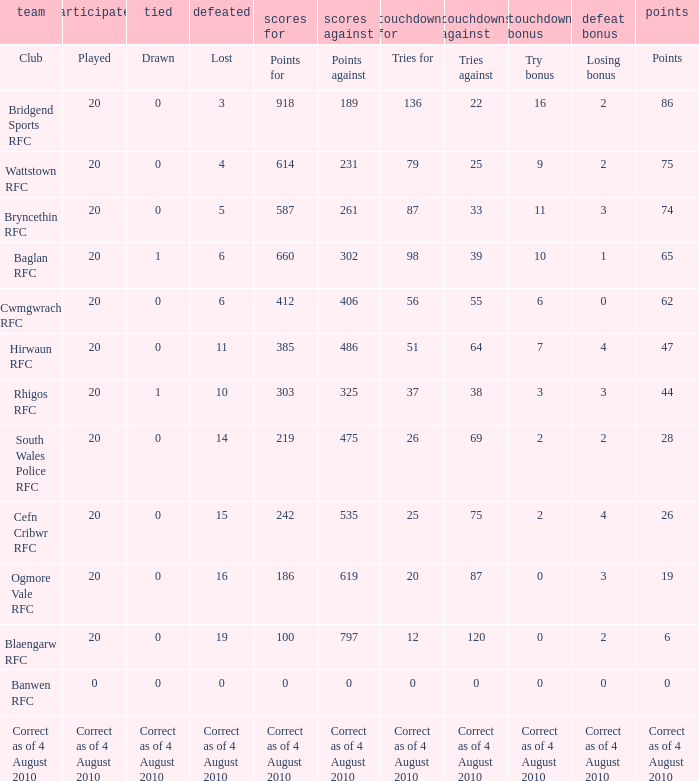Could you parse the entire table? {'header': ['team', 'participated', 'tied', 'defeated', 'scores for', 'scores against', 'touchdowns for', 'touchdowns against', 'touchdown bonus', 'defeat bonus', 'points'], 'rows': [['Club', 'Played', 'Drawn', 'Lost', 'Points for', 'Points against', 'Tries for', 'Tries against', 'Try bonus', 'Losing bonus', 'Points'], ['Bridgend Sports RFC', '20', '0', '3', '918', '189', '136', '22', '16', '2', '86'], ['Wattstown RFC', '20', '0', '4', '614', '231', '79', '25', '9', '2', '75'], ['Bryncethin RFC', '20', '0', '5', '587', '261', '87', '33', '11', '3', '74'], ['Baglan RFC', '20', '1', '6', '660', '302', '98', '39', '10', '1', '65'], ['Cwmgwrach RFC', '20', '0', '6', '412', '406', '56', '55', '6', '0', '62'], ['Hirwaun RFC', '20', '0', '11', '385', '486', '51', '64', '7', '4', '47'], ['Rhigos RFC', '20', '1', '10', '303', '325', '37', '38', '3', '3', '44'], ['South Wales Police RFC', '20', '0', '14', '219', '475', '26', '69', '2', '2', '28'], ['Cefn Cribwr RFC', '20', '0', '15', '242', '535', '25', '75', '2', '4', '26'], ['Ogmore Vale RFC', '20', '0', '16', '186', '619', '20', '87', '0', '3', '19'], ['Blaengarw RFC', '20', '0', '19', '100', '797', '12', '120', '0', '2', '6'], ['Banwen RFC', '0', '0', '0', '0', '0', '0', '0', '0', '0', '0'], ['Correct as of 4 August 2010', 'Correct as of 4 August 2010', 'Correct as of 4 August 2010', 'Correct as of 4 August 2010', 'Correct as of 4 August 2010', 'Correct as of 4 August 2010', 'Correct as of 4 August 2010', 'Correct as of 4 August 2010', 'Correct as of 4 August 2010', 'Correct as of 4 August 2010', 'Correct as of 4 August 2010']]} What are the counterpoints when drawn is represented? Points against. 